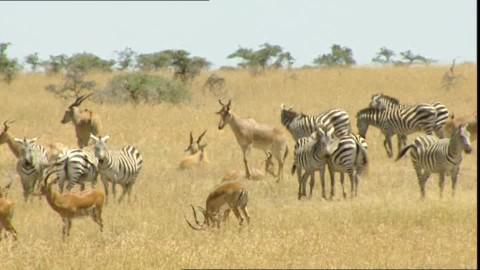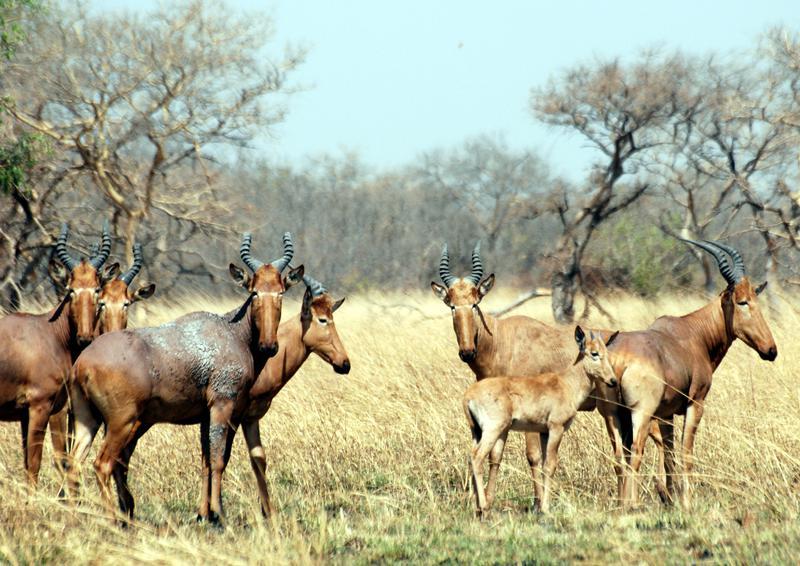The first image is the image on the left, the second image is the image on the right. For the images shown, is this caption "There is one horned mammal sitting in the left image, and multiple standing in the right." true? Answer yes or no. Yes. The first image is the image on the left, the second image is the image on the right. Analyze the images presented: Is the assertion "There are less than 5 animals." valid? Answer yes or no. No. 